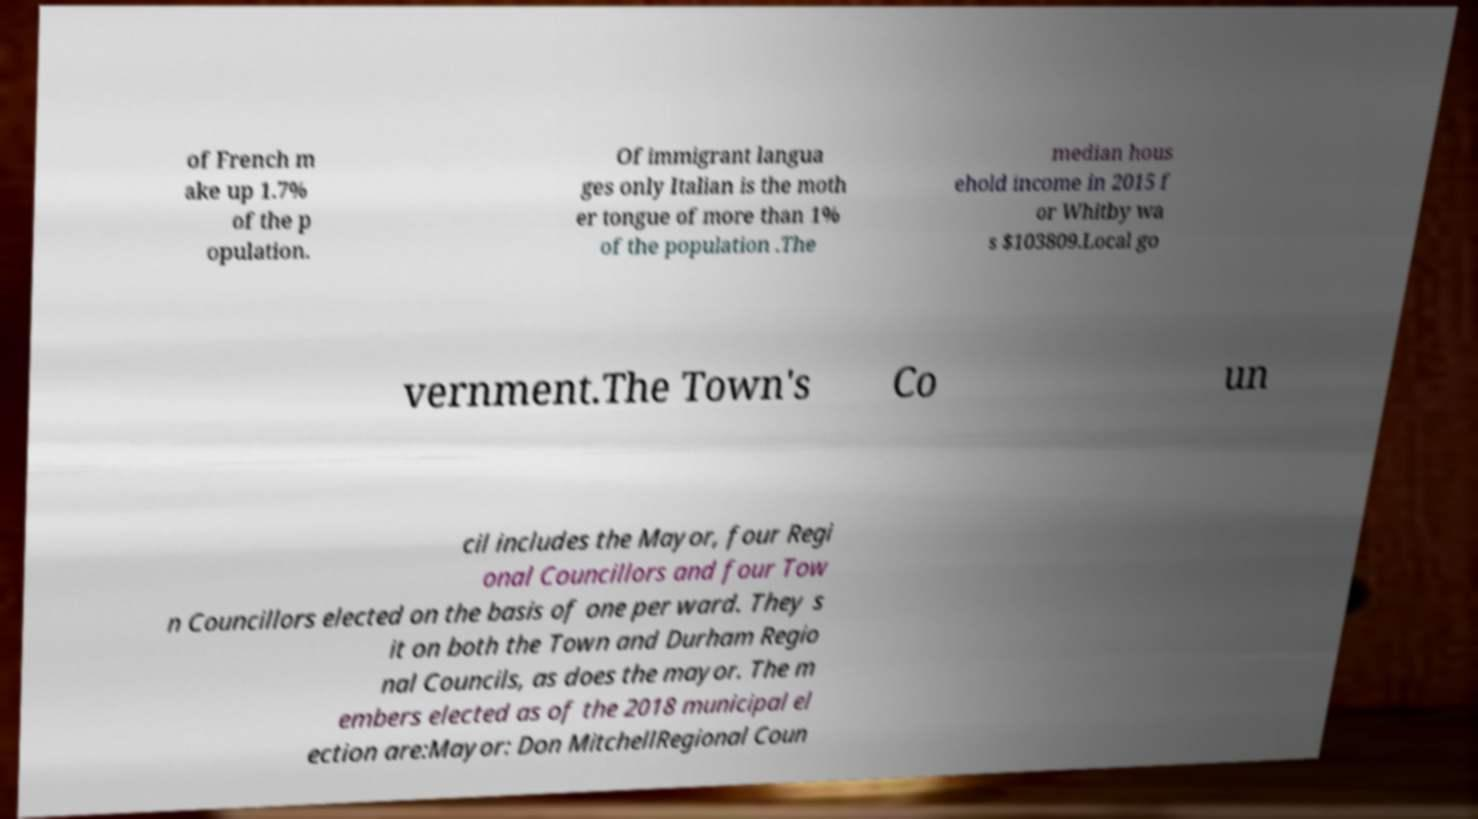Please read and relay the text visible in this image. What does it say? of French m ake up 1.7% of the p opulation. Of immigrant langua ges only Italian is the moth er tongue of more than 1% of the population .The median hous ehold income in 2015 f or Whitby wa s $103809.Local go vernment.The Town's Co un cil includes the Mayor, four Regi onal Councillors and four Tow n Councillors elected on the basis of one per ward. They s it on both the Town and Durham Regio nal Councils, as does the mayor. The m embers elected as of the 2018 municipal el ection are:Mayor: Don MitchellRegional Coun 